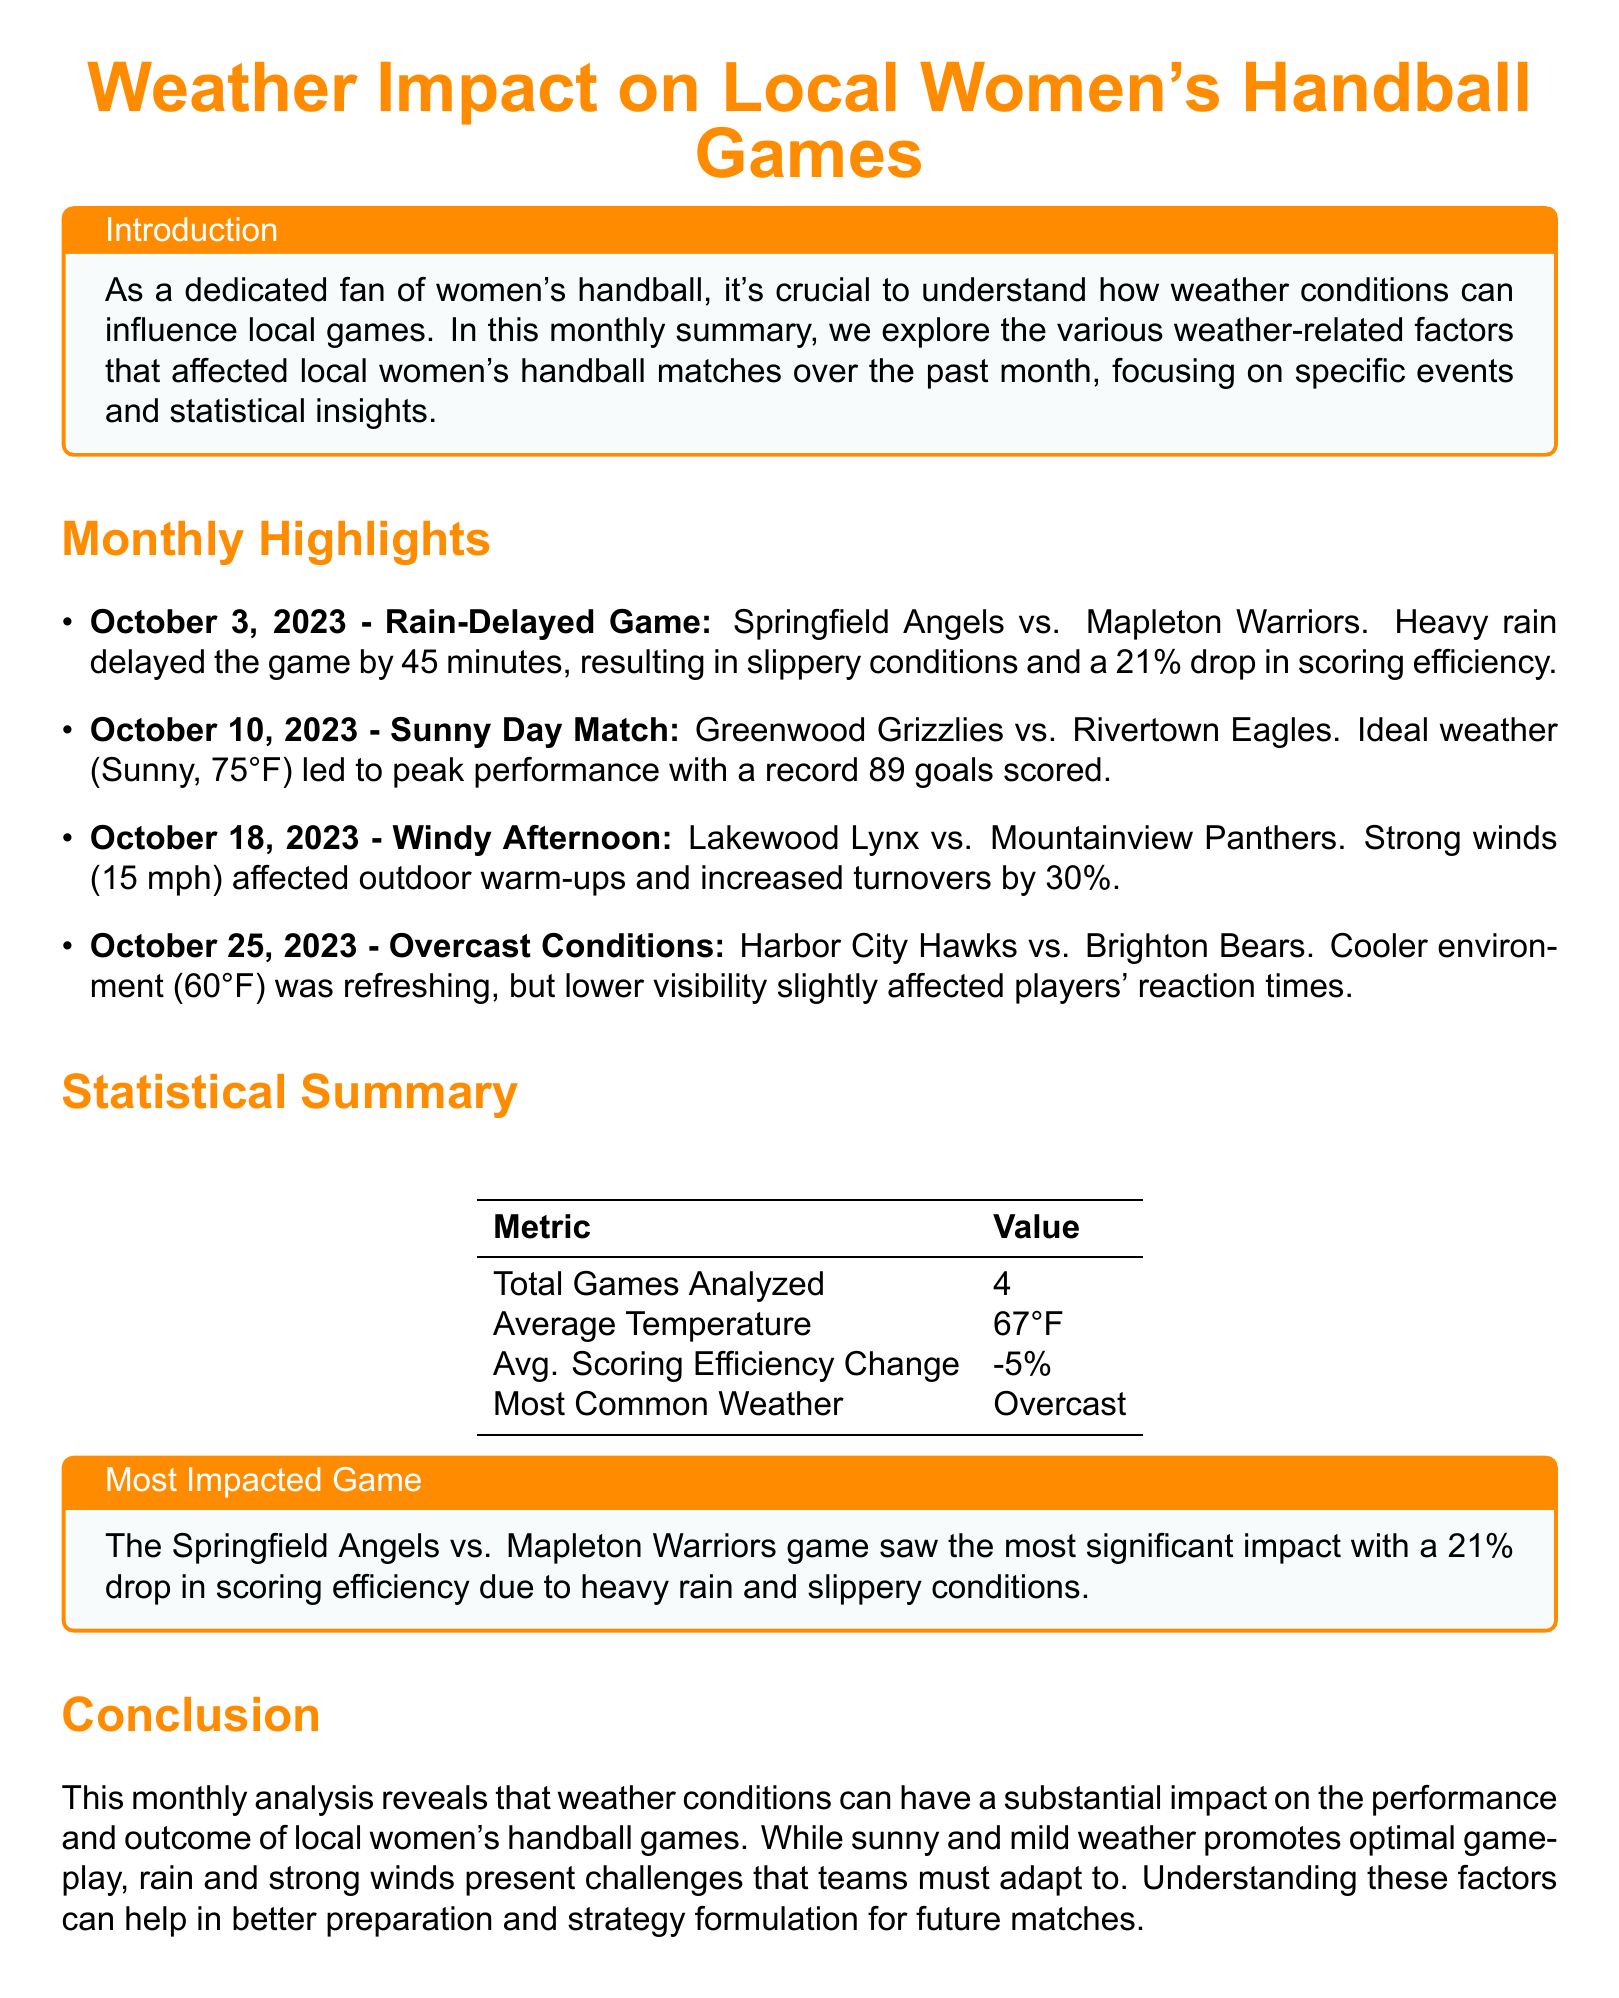What is the date of the rain-delayed game? The rain-delayed game occurred on October 3, 2023, as noted in the highlights section.
Answer: October 3, 2023 How much time was the game delayed due to rain? The document specifies that the game was delayed by 45 minutes because of heavy rain.
Answer: 45 minutes What was the scoring efficiency drop in the rain-delayed game? According to the highlights, the rain-delayed game saw a 21% drop in scoring efficiency.
Answer: 21% What was the average temperature during the analyzed games? The statistical summary indicates the average temperature was 67°F across the games.
Answer: 67°F What was the most common weather condition during the games? The statistical summary highlights that the most common weather condition recorded was overcast.
Answer: Overcast Which game had the peak performance in terms of goals scored? The highlights mention that the Greenwood Grizzlies vs. Rivertown Eagles match achieved a record 89 goals scored.
Answer: Greenwood Grizzlies vs. Rivertown Eagles What was the impact of strong winds during the Lakewood Lynx vs. Mountainview Panthers game? In the document, it is noted that strong winds increased turnovers by 30% during that game.
Answer: 30% What is the title of this document? The title of the document is explicitly stated at the beginning as "Weather Impact on Local Women's Handball Games."
Answer: Weather Impact on Local Women's Handball Games What were the cooler conditions during the Harbor City Hawks vs. Brighton Bears game? The document mentions that the cooler environment was 60°F during this game.
Answer: 60°F 